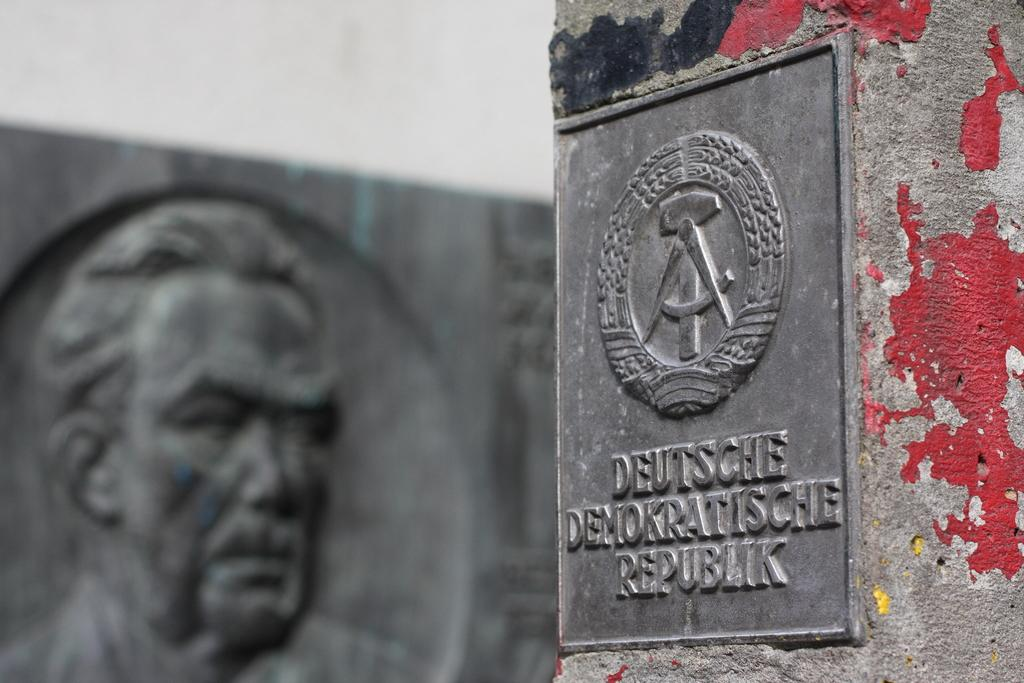What is located on the right side of the image? There is a board on the right side of the image. What can be seen on the board? The board has a logo and texts on it. How is the board positioned in the image? The board is attached to a wall. What can be seen in the background of the image? There is a sculpture in the background of the image. How is the background of the image depicted? The background is blurred. Can you tell me how many people are wearing a scarf in the image? There are no people present in the image, so it is not possible to determine if anyone is wearing a scarf. What type of control system is used to operate the sculpture in the image? There is no control system mentioned or visible in the image, as it only features a board, a wall, and a blurred background with a sculpture. 